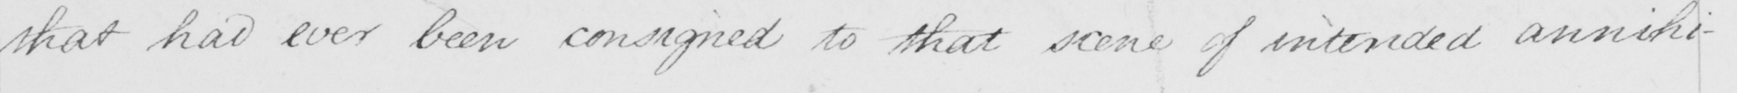What is written in this line of handwriting? that had ever been consigned to that scene of intended annihi- 